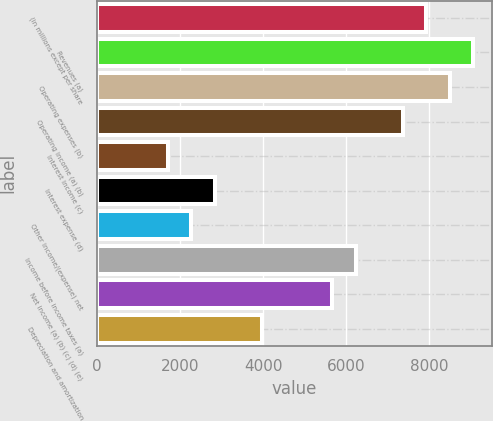Convert chart. <chart><loc_0><loc_0><loc_500><loc_500><bar_chart><fcel>(in millions except per share<fcel>Revenues (a)<fcel>Operating expenses (b)<fcel>Operating income (a) (b)<fcel>Interest income (c)<fcel>Interest expense (d)<fcel>Other income/(expense) net<fcel>Income before income taxes (a)<fcel>Net income (a) (b) (c) (d) (e)<fcel>Depreciation and amortization<nl><fcel>7930.58<fcel>9063.46<fcel>8497.02<fcel>7364.14<fcel>1699.74<fcel>2832.62<fcel>2266.18<fcel>6231.26<fcel>5664.82<fcel>3965.5<nl></chart> 